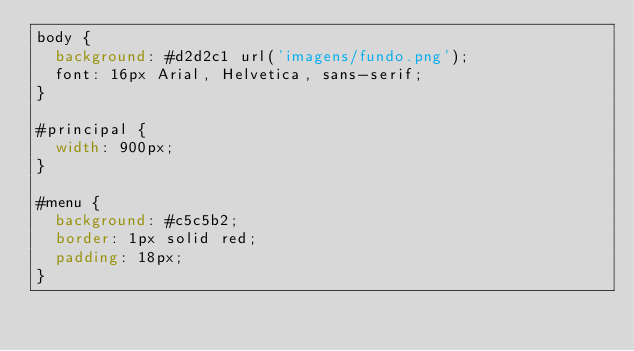<code> <loc_0><loc_0><loc_500><loc_500><_CSS_>body {
	background: #d2d2c1 url('imagens/fundo.png');
	font: 16px Arial, Helvetica, sans-serif;
}

#principal {	
	width: 900px;
}

#menu {
	background: #c5c5b2;
	border: 1px solid red;
	padding: 18px;
}</code> 